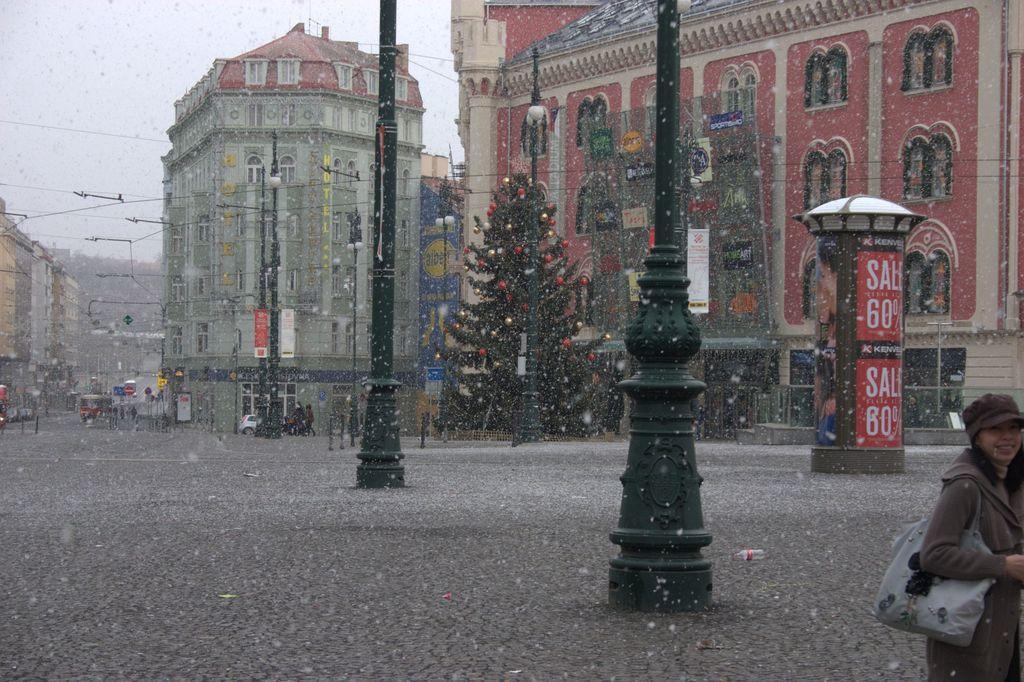Describe this image in one or two sentences. In this image, we can see a person standing and wearing a cap and a bag. In the background, there are poles along with wires and we can see lights, a booth, a christmas tree and there are buildings and we can see vehicles and some other boards on the road. At the top, there is sky. 